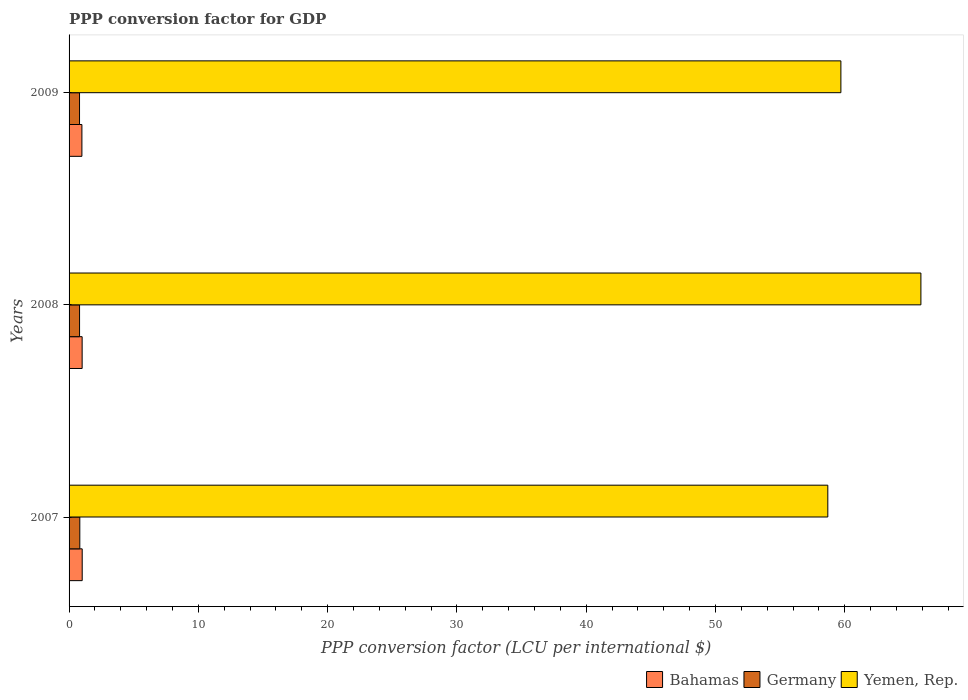How many different coloured bars are there?
Offer a terse response. 3. Are the number of bars per tick equal to the number of legend labels?
Make the answer very short. Yes. How many bars are there on the 3rd tick from the top?
Your response must be concise. 3. What is the label of the 3rd group of bars from the top?
Provide a succinct answer. 2007. In how many cases, is the number of bars for a given year not equal to the number of legend labels?
Keep it short and to the point. 0. What is the PPP conversion factor for GDP in Germany in 2009?
Provide a succinct answer. 0.81. Across all years, what is the maximum PPP conversion factor for GDP in Germany?
Provide a short and direct response. 0.83. Across all years, what is the minimum PPP conversion factor for GDP in Yemen, Rep.?
Keep it short and to the point. 58.69. In which year was the PPP conversion factor for GDP in Bahamas maximum?
Offer a terse response. 2007. In which year was the PPP conversion factor for GDP in Yemen, Rep. minimum?
Provide a succinct answer. 2007. What is the total PPP conversion factor for GDP in Yemen, Rep. in the graph?
Offer a terse response. 184.28. What is the difference between the PPP conversion factor for GDP in Germany in 2007 and that in 2008?
Offer a terse response. 0.02. What is the difference between the PPP conversion factor for GDP in Bahamas in 2009 and the PPP conversion factor for GDP in Yemen, Rep. in 2007?
Give a very brief answer. -57.7. What is the average PPP conversion factor for GDP in Germany per year?
Your answer should be very brief. 0.82. In the year 2008, what is the difference between the PPP conversion factor for GDP in Germany and PPP conversion factor for GDP in Bahamas?
Make the answer very short. -0.2. In how many years, is the PPP conversion factor for GDP in Bahamas greater than 8 LCU?
Your answer should be compact. 0. What is the ratio of the PPP conversion factor for GDP in Bahamas in 2007 to that in 2008?
Provide a short and direct response. 1. Is the PPP conversion factor for GDP in Germany in 2007 less than that in 2008?
Ensure brevity in your answer.  No. Is the difference between the PPP conversion factor for GDP in Germany in 2007 and 2009 greater than the difference between the PPP conversion factor for GDP in Bahamas in 2007 and 2009?
Provide a succinct answer. No. What is the difference between the highest and the second highest PPP conversion factor for GDP in Yemen, Rep.?
Provide a succinct answer. 6.19. What is the difference between the highest and the lowest PPP conversion factor for GDP in Yemen, Rep.?
Make the answer very short. 7.2. In how many years, is the PPP conversion factor for GDP in Yemen, Rep. greater than the average PPP conversion factor for GDP in Yemen, Rep. taken over all years?
Ensure brevity in your answer.  1. What does the 1st bar from the top in 2009 represents?
Offer a terse response. Yemen, Rep. What does the 1st bar from the bottom in 2008 represents?
Your answer should be very brief. Bahamas. What is the difference between two consecutive major ticks on the X-axis?
Your answer should be compact. 10. Are the values on the major ticks of X-axis written in scientific E-notation?
Ensure brevity in your answer.  No. Does the graph contain any zero values?
Offer a very short reply. No. Does the graph contain grids?
Offer a terse response. No. Where does the legend appear in the graph?
Offer a very short reply. Bottom right. How many legend labels are there?
Your answer should be compact. 3. How are the legend labels stacked?
Offer a very short reply. Horizontal. What is the title of the graph?
Your answer should be compact. PPP conversion factor for GDP. What is the label or title of the X-axis?
Ensure brevity in your answer.  PPP conversion factor (LCU per international $). What is the label or title of the Y-axis?
Your answer should be very brief. Years. What is the PPP conversion factor (LCU per international $) in Bahamas in 2007?
Provide a short and direct response. 1.02. What is the PPP conversion factor (LCU per international $) in Germany in 2007?
Ensure brevity in your answer.  0.83. What is the PPP conversion factor (LCU per international $) of Yemen, Rep. in 2007?
Your answer should be very brief. 58.69. What is the PPP conversion factor (LCU per international $) in Bahamas in 2008?
Your answer should be very brief. 1.01. What is the PPP conversion factor (LCU per international $) in Germany in 2008?
Ensure brevity in your answer.  0.81. What is the PPP conversion factor (LCU per international $) in Yemen, Rep. in 2008?
Ensure brevity in your answer.  65.89. What is the PPP conversion factor (LCU per international $) of Bahamas in 2009?
Ensure brevity in your answer.  0.99. What is the PPP conversion factor (LCU per international $) of Germany in 2009?
Offer a very short reply. 0.81. What is the PPP conversion factor (LCU per international $) of Yemen, Rep. in 2009?
Your answer should be compact. 59.7. Across all years, what is the maximum PPP conversion factor (LCU per international $) of Bahamas?
Give a very brief answer. 1.02. Across all years, what is the maximum PPP conversion factor (LCU per international $) in Germany?
Keep it short and to the point. 0.83. Across all years, what is the maximum PPP conversion factor (LCU per international $) of Yemen, Rep.?
Offer a very short reply. 65.89. Across all years, what is the minimum PPP conversion factor (LCU per international $) in Bahamas?
Your answer should be compact. 0.99. Across all years, what is the minimum PPP conversion factor (LCU per international $) in Germany?
Provide a short and direct response. 0.81. Across all years, what is the minimum PPP conversion factor (LCU per international $) in Yemen, Rep.?
Make the answer very short. 58.69. What is the total PPP conversion factor (LCU per international $) of Bahamas in the graph?
Keep it short and to the point. 3.02. What is the total PPP conversion factor (LCU per international $) in Germany in the graph?
Provide a short and direct response. 2.45. What is the total PPP conversion factor (LCU per international $) of Yemen, Rep. in the graph?
Make the answer very short. 184.28. What is the difference between the PPP conversion factor (LCU per international $) of Bahamas in 2007 and that in 2008?
Provide a succinct answer. 0. What is the difference between the PPP conversion factor (LCU per international $) in Germany in 2007 and that in 2008?
Your answer should be compact. 0.02. What is the difference between the PPP conversion factor (LCU per international $) of Yemen, Rep. in 2007 and that in 2008?
Your answer should be compact. -7.2. What is the difference between the PPP conversion factor (LCU per international $) in Bahamas in 2007 and that in 2009?
Your answer should be compact. 0.02. What is the difference between the PPP conversion factor (LCU per international $) in Germany in 2007 and that in 2009?
Keep it short and to the point. 0.02. What is the difference between the PPP conversion factor (LCU per international $) of Yemen, Rep. in 2007 and that in 2009?
Provide a succinct answer. -1.01. What is the difference between the PPP conversion factor (LCU per international $) of Bahamas in 2008 and that in 2009?
Make the answer very short. 0.02. What is the difference between the PPP conversion factor (LCU per international $) in Germany in 2008 and that in 2009?
Make the answer very short. 0. What is the difference between the PPP conversion factor (LCU per international $) in Yemen, Rep. in 2008 and that in 2009?
Your response must be concise. 6.19. What is the difference between the PPP conversion factor (LCU per international $) of Bahamas in 2007 and the PPP conversion factor (LCU per international $) of Germany in 2008?
Your response must be concise. 0.2. What is the difference between the PPP conversion factor (LCU per international $) of Bahamas in 2007 and the PPP conversion factor (LCU per international $) of Yemen, Rep. in 2008?
Your answer should be compact. -64.87. What is the difference between the PPP conversion factor (LCU per international $) of Germany in 2007 and the PPP conversion factor (LCU per international $) of Yemen, Rep. in 2008?
Provide a short and direct response. -65.06. What is the difference between the PPP conversion factor (LCU per international $) in Bahamas in 2007 and the PPP conversion factor (LCU per international $) in Germany in 2009?
Your answer should be very brief. 0.21. What is the difference between the PPP conversion factor (LCU per international $) in Bahamas in 2007 and the PPP conversion factor (LCU per international $) in Yemen, Rep. in 2009?
Your answer should be compact. -58.69. What is the difference between the PPP conversion factor (LCU per international $) in Germany in 2007 and the PPP conversion factor (LCU per international $) in Yemen, Rep. in 2009?
Your answer should be compact. -58.87. What is the difference between the PPP conversion factor (LCU per international $) of Bahamas in 2008 and the PPP conversion factor (LCU per international $) of Germany in 2009?
Ensure brevity in your answer.  0.2. What is the difference between the PPP conversion factor (LCU per international $) in Bahamas in 2008 and the PPP conversion factor (LCU per international $) in Yemen, Rep. in 2009?
Your answer should be compact. -58.69. What is the difference between the PPP conversion factor (LCU per international $) of Germany in 2008 and the PPP conversion factor (LCU per international $) of Yemen, Rep. in 2009?
Your answer should be compact. -58.89. What is the average PPP conversion factor (LCU per international $) in Germany per year?
Offer a terse response. 0.82. What is the average PPP conversion factor (LCU per international $) of Yemen, Rep. per year?
Provide a short and direct response. 61.43. In the year 2007, what is the difference between the PPP conversion factor (LCU per international $) in Bahamas and PPP conversion factor (LCU per international $) in Germany?
Give a very brief answer. 0.19. In the year 2007, what is the difference between the PPP conversion factor (LCU per international $) in Bahamas and PPP conversion factor (LCU per international $) in Yemen, Rep.?
Give a very brief answer. -57.67. In the year 2007, what is the difference between the PPP conversion factor (LCU per international $) of Germany and PPP conversion factor (LCU per international $) of Yemen, Rep.?
Your response must be concise. -57.86. In the year 2008, what is the difference between the PPP conversion factor (LCU per international $) in Bahamas and PPP conversion factor (LCU per international $) in Germany?
Offer a very short reply. 0.2. In the year 2008, what is the difference between the PPP conversion factor (LCU per international $) in Bahamas and PPP conversion factor (LCU per international $) in Yemen, Rep.?
Your answer should be compact. -64.88. In the year 2008, what is the difference between the PPP conversion factor (LCU per international $) of Germany and PPP conversion factor (LCU per international $) of Yemen, Rep.?
Your response must be concise. -65.08. In the year 2009, what is the difference between the PPP conversion factor (LCU per international $) of Bahamas and PPP conversion factor (LCU per international $) of Germany?
Your response must be concise. 0.18. In the year 2009, what is the difference between the PPP conversion factor (LCU per international $) in Bahamas and PPP conversion factor (LCU per international $) in Yemen, Rep.?
Offer a very short reply. -58.71. In the year 2009, what is the difference between the PPP conversion factor (LCU per international $) of Germany and PPP conversion factor (LCU per international $) of Yemen, Rep.?
Ensure brevity in your answer.  -58.89. What is the ratio of the PPP conversion factor (LCU per international $) of Germany in 2007 to that in 2008?
Your response must be concise. 1.02. What is the ratio of the PPP conversion factor (LCU per international $) of Yemen, Rep. in 2007 to that in 2008?
Make the answer very short. 0.89. What is the ratio of the PPP conversion factor (LCU per international $) of Bahamas in 2007 to that in 2009?
Provide a succinct answer. 1.02. What is the ratio of the PPP conversion factor (LCU per international $) in Germany in 2007 to that in 2009?
Provide a succinct answer. 1.03. What is the ratio of the PPP conversion factor (LCU per international $) in Yemen, Rep. in 2007 to that in 2009?
Your answer should be compact. 0.98. What is the ratio of the PPP conversion factor (LCU per international $) of Bahamas in 2008 to that in 2009?
Give a very brief answer. 1.02. What is the ratio of the PPP conversion factor (LCU per international $) in Germany in 2008 to that in 2009?
Your response must be concise. 1. What is the ratio of the PPP conversion factor (LCU per international $) in Yemen, Rep. in 2008 to that in 2009?
Offer a very short reply. 1.1. What is the difference between the highest and the second highest PPP conversion factor (LCU per international $) of Bahamas?
Provide a succinct answer. 0. What is the difference between the highest and the second highest PPP conversion factor (LCU per international $) of Germany?
Your answer should be compact. 0.02. What is the difference between the highest and the second highest PPP conversion factor (LCU per international $) of Yemen, Rep.?
Ensure brevity in your answer.  6.19. What is the difference between the highest and the lowest PPP conversion factor (LCU per international $) of Bahamas?
Your response must be concise. 0.02. What is the difference between the highest and the lowest PPP conversion factor (LCU per international $) in Germany?
Make the answer very short. 0.02. What is the difference between the highest and the lowest PPP conversion factor (LCU per international $) in Yemen, Rep.?
Offer a terse response. 7.2. 